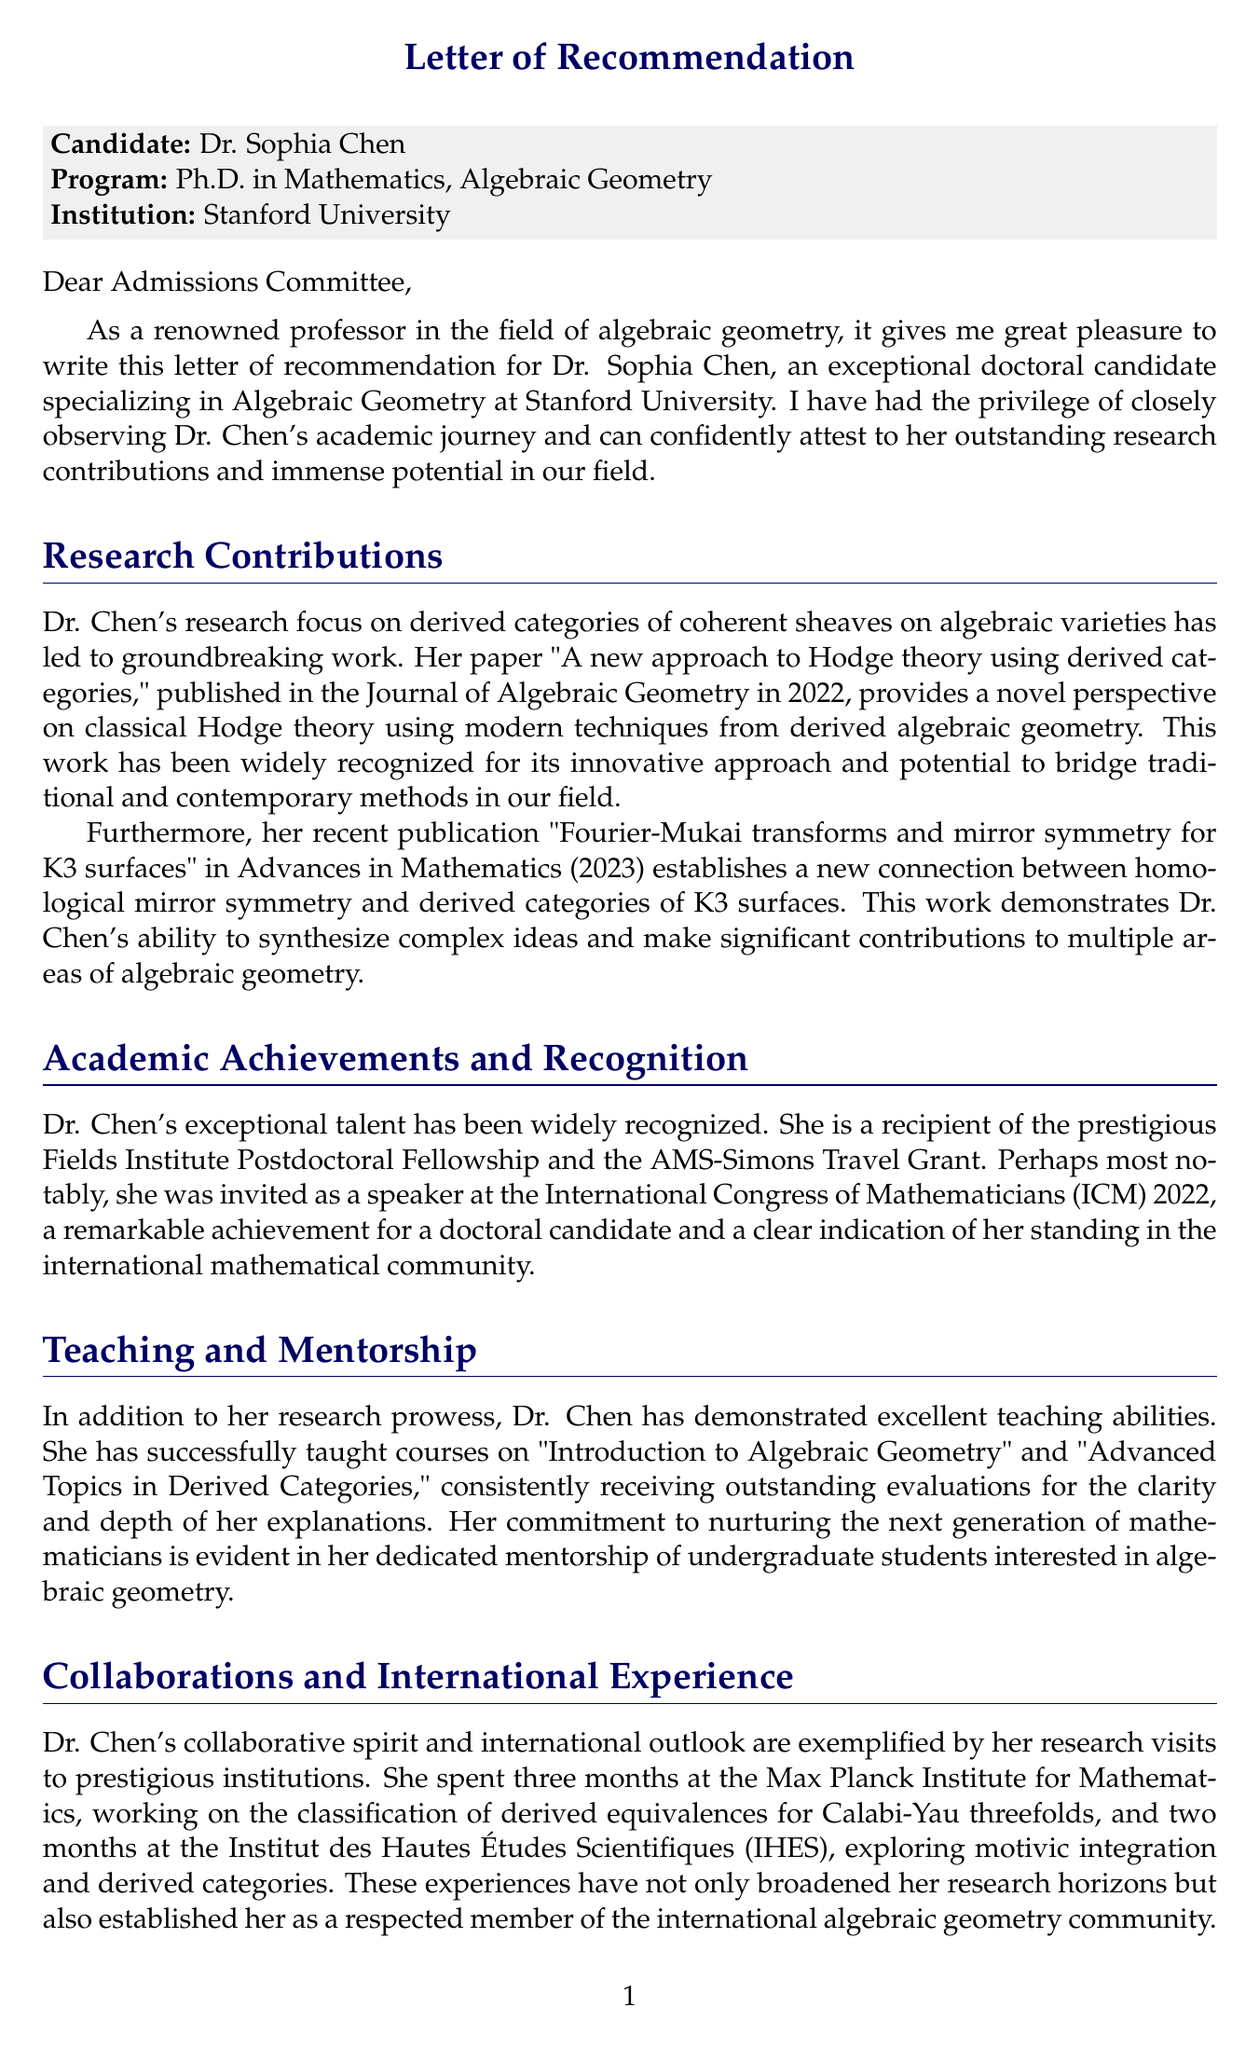What is the candidate's name? The candidate's name is stated at the beginning of the letter.
Answer: Dr. Sophia Chen Which university is the candidate attending? The university is mentioned in the context of the candidate's education.
Answer: Stanford University What is the title of Dr. Chen's 2022 publication? The title is provided in the section discussing her research contributions.
Answer: A new approach to Hodge theory using derived categories What prestigious fellowship has Dr. Chen received? The letter highlights a significant academic achievement of the candidate.
Answer: Fields Institute Postdoctoral Fellowship How many months did Dr. Chen spend at the Max Planck Institute for Mathematics? This detail is found in the section about her collaborations and international experience.
Answer: 3 months What course did Dr. Chen teach that pertains to derived categories? This information is included in the discussion of her teaching experience.
Answer: Advanced Topics in Derived Categories What potential impact does Dr. Chen have in algebraic geometry? The letter mentions promising contributions related to her research focus.
Answer: Bridging the gap between classical algebraic geometry and modern derived techniques In what year was Dr. Chen invited to speak at the International Congress of Mathematicians? This detail is provided in the section regarding her academic achievements.
Answer: 2022 What is the strength of the recommendation given for Dr. Chen? The strength of the recommendation is explicitly stated in the conclusion of the letter.
Answer: Highest possible recommendation 